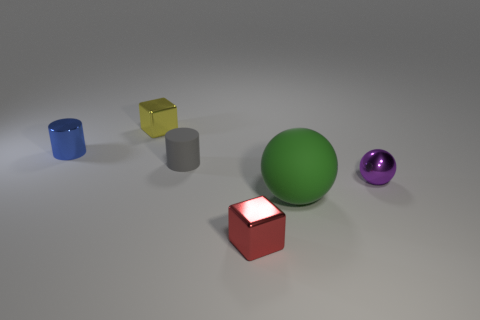There is a yellow block that is the same size as the gray matte object; what is it made of?
Provide a succinct answer. Metal. There is a cube to the left of the tiny shiny cube in front of the metallic cube that is left of the red metallic block; what is it made of?
Keep it short and to the point. Metal. The metallic cylinder is what color?
Keep it short and to the point. Blue. What number of big objects are green rubber objects or matte cubes?
Your answer should be very brief. 1. Does the sphere that is behind the green matte sphere have the same material as the cube that is in front of the rubber cylinder?
Your answer should be very brief. Yes. Are there any matte things?
Your answer should be compact. Yes. Is the number of small spheres behind the small gray thing greater than the number of yellow shiny things that are left of the small yellow block?
Your response must be concise. No. There is another thing that is the same shape as the tiny purple metallic object; what is its material?
Provide a succinct answer. Rubber. Is there anything else that has the same size as the red metallic block?
Keep it short and to the point. Yes. There is a cylinder that is in front of the tiny metal cylinder; is it the same color as the small shiny cube that is behind the small gray cylinder?
Offer a terse response. No. 